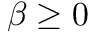Convert formula to latex. <formula><loc_0><loc_0><loc_500><loc_500>\beta \geq 0</formula> 